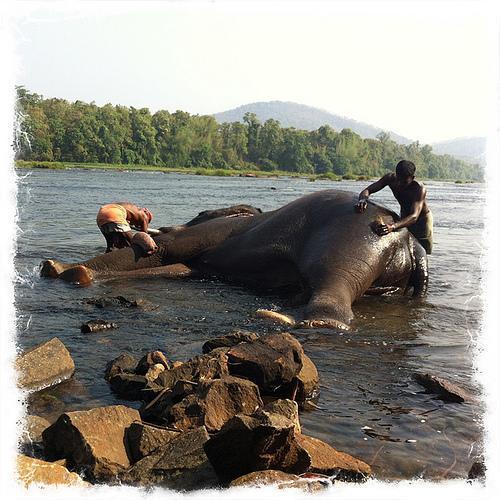How many people in the photo?
Give a very brief answer. 2. 